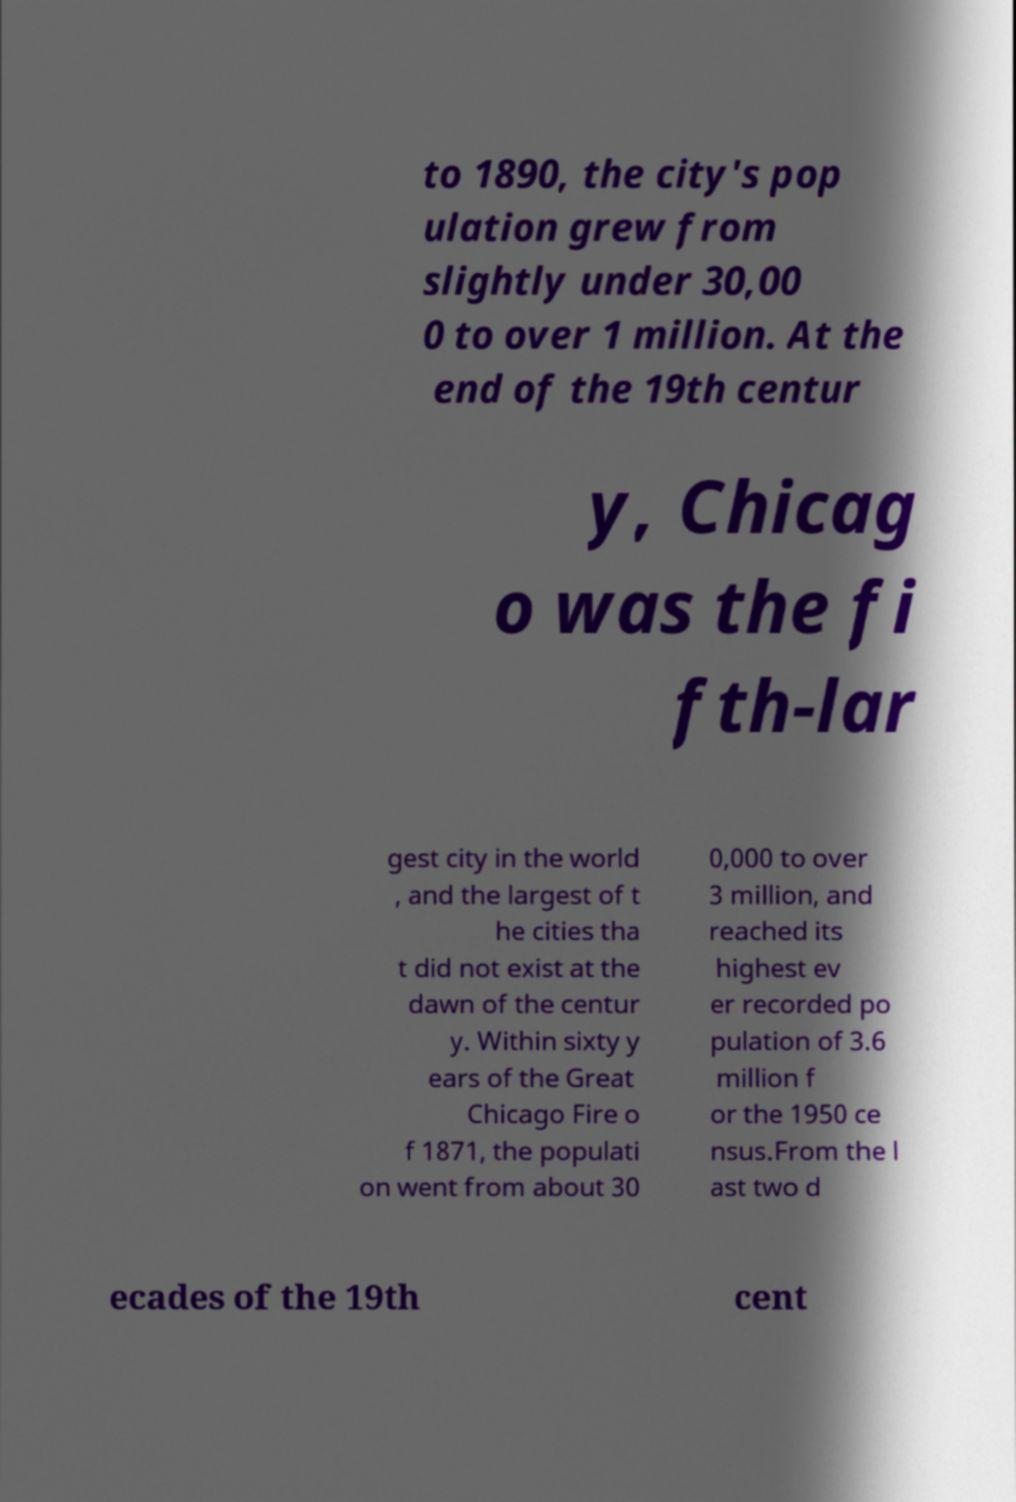Can you accurately transcribe the text from the provided image for me? to 1890, the city's pop ulation grew from slightly under 30,00 0 to over 1 million. At the end of the 19th centur y, Chicag o was the fi fth-lar gest city in the world , and the largest of t he cities tha t did not exist at the dawn of the centur y. Within sixty y ears of the Great Chicago Fire o f 1871, the populati on went from about 30 0,000 to over 3 million, and reached its highest ev er recorded po pulation of 3.6 million f or the 1950 ce nsus.From the l ast two d ecades of the 19th cent 